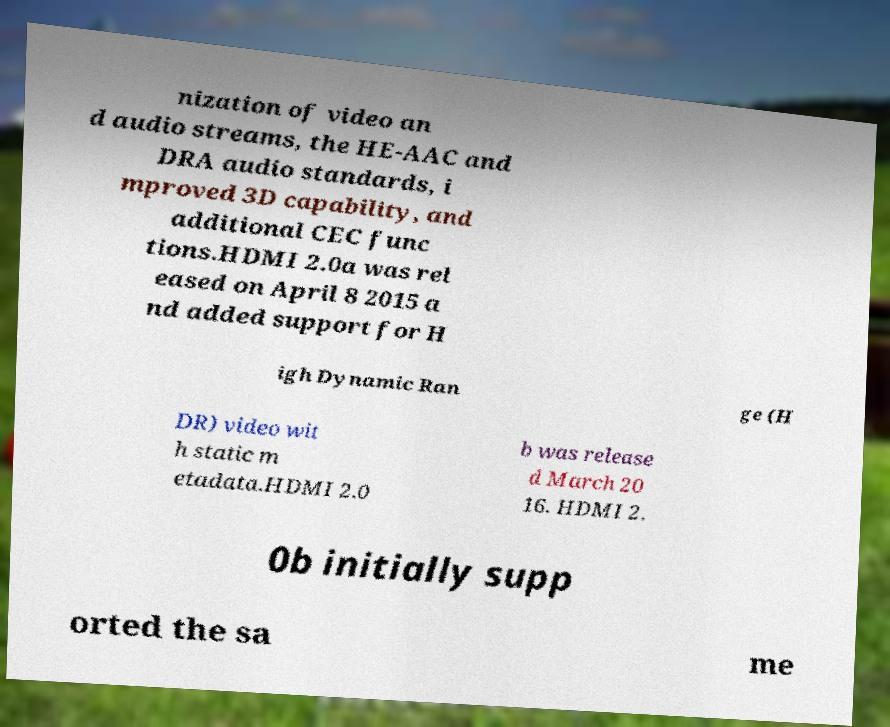For documentation purposes, I need the text within this image transcribed. Could you provide that? nization of video an d audio streams, the HE-AAC and DRA audio standards, i mproved 3D capability, and additional CEC func tions.HDMI 2.0a was rel eased on April 8 2015 a nd added support for H igh Dynamic Ran ge (H DR) video wit h static m etadata.HDMI 2.0 b was release d March 20 16. HDMI 2. 0b initially supp orted the sa me 